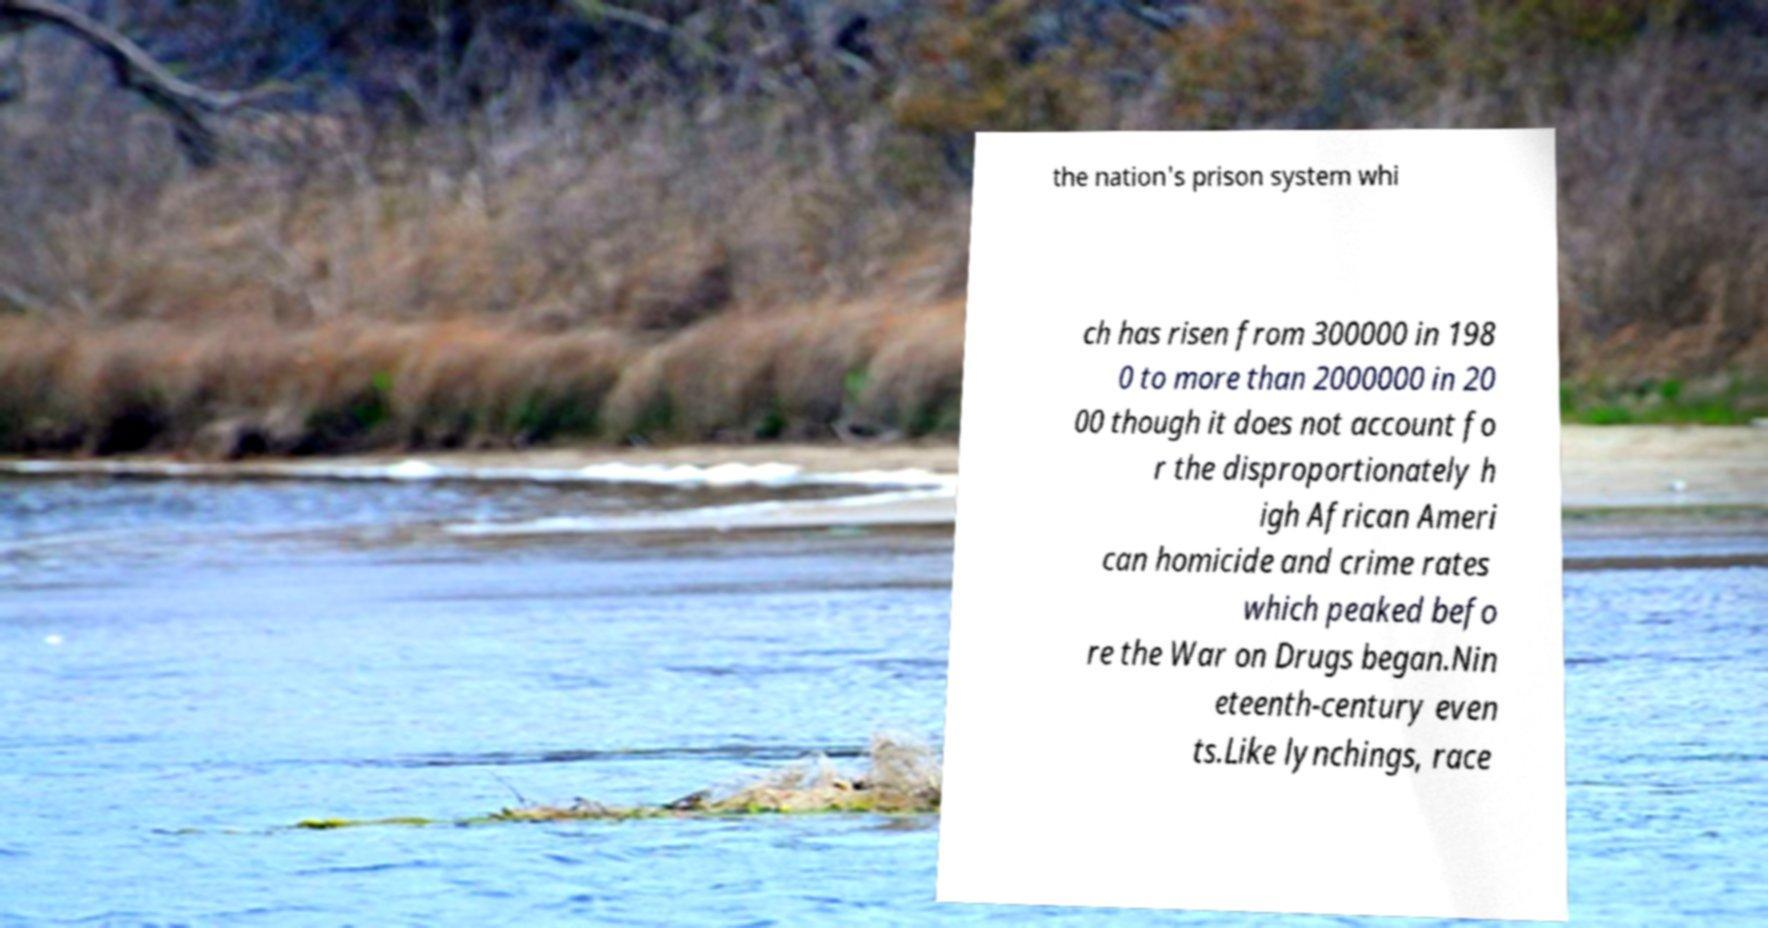Could you assist in decoding the text presented in this image and type it out clearly? the nation's prison system whi ch has risen from 300000 in 198 0 to more than 2000000 in 20 00 though it does not account fo r the disproportionately h igh African Ameri can homicide and crime rates which peaked befo re the War on Drugs began.Nin eteenth-century even ts.Like lynchings, race 